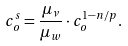Convert formula to latex. <formula><loc_0><loc_0><loc_500><loc_500>c _ { o } ^ { s } = \frac { \mu _ { \nu } } { \mu _ { w } } \cdot c _ { o } ^ { 1 - n / p } .</formula> 